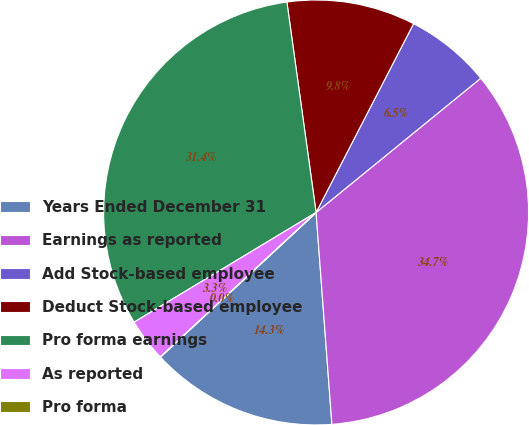Convert chart to OTSL. <chart><loc_0><loc_0><loc_500><loc_500><pie_chart><fcel>Years Ended December 31<fcel>Earnings as reported<fcel>Add Stock-based employee<fcel>Deduct Stock-based employee<fcel>Pro forma earnings<fcel>As reported<fcel>Pro forma<nl><fcel>14.27%<fcel>34.7%<fcel>6.53%<fcel>9.78%<fcel>31.44%<fcel>3.27%<fcel>0.01%<nl></chart> 